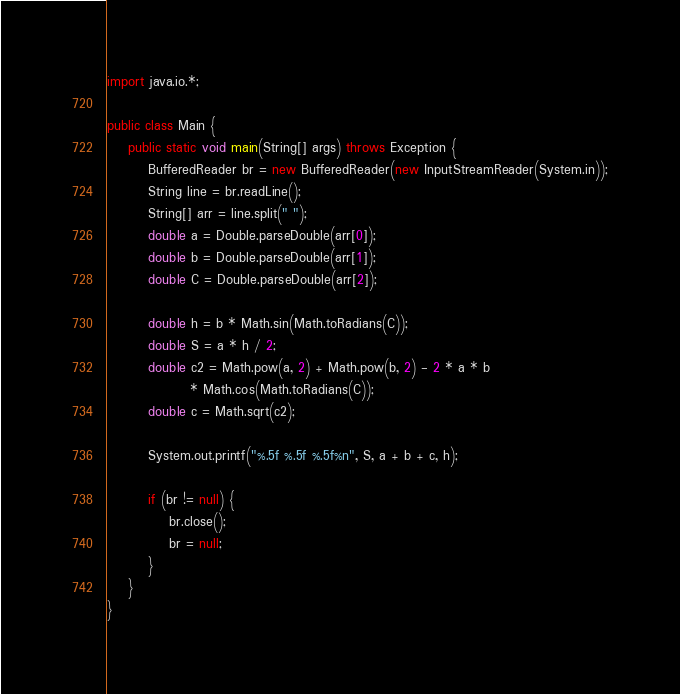<code> <loc_0><loc_0><loc_500><loc_500><_Java_>import java.io.*;
 
public class Main {
    public static void main(String[] args) throws Exception {
        BufferedReader br = new BufferedReader(new InputStreamReader(System.in));
        String line = br.readLine();
        String[] arr = line.split(" ");
        double a = Double.parseDouble(arr[0]);
        double b = Double.parseDouble(arr[1]);
        double C = Double.parseDouble(arr[2]);
 
        double h = b * Math.sin(Math.toRadians(C));
        double S = a * h / 2;
        double c2 = Math.pow(a, 2) + Math.pow(b, 2) - 2 * a * b
                * Math.cos(Math.toRadians(C));
        double c = Math.sqrt(c2);
 
        System.out.printf("%.5f %.5f %.5f%n", S, a + b + c, h);
 
        if (br != null) {
            br.close();
            br = null;
        }
    }
}</code> 